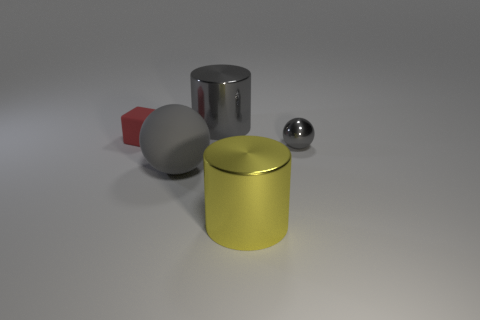What size is the metallic object that is the same color as the shiny ball?
Keep it short and to the point. Large. There is a metal object behind the tiny red matte object; does it have the same shape as the big shiny object in front of the small metallic thing?
Your answer should be compact. Yes. Are there any big brown cylinders?
Your response must be concise. No. The big thing that is the same shape as the tiny metallic object is what color?
Offer a terse response. Gray. What color is the shiny thing that is the same size as the gray metallic cylinder?
Give a very brief answer. Yellow. Is the yellow cylinder made of the same material as the small block?
Provide a succinct answer. No. How many tiny spheres have the same color as the large ball?
Your answer should be very brief. 1. Is the small sphere the same color as the large ball?
Your answer should be compact. Yes. There is a large thing behind the tiny matte cube; what is its material?
Your response must be concise. Metal. How many large things are rubber balls or matte objects?
Provide a succinct answer. 1. 